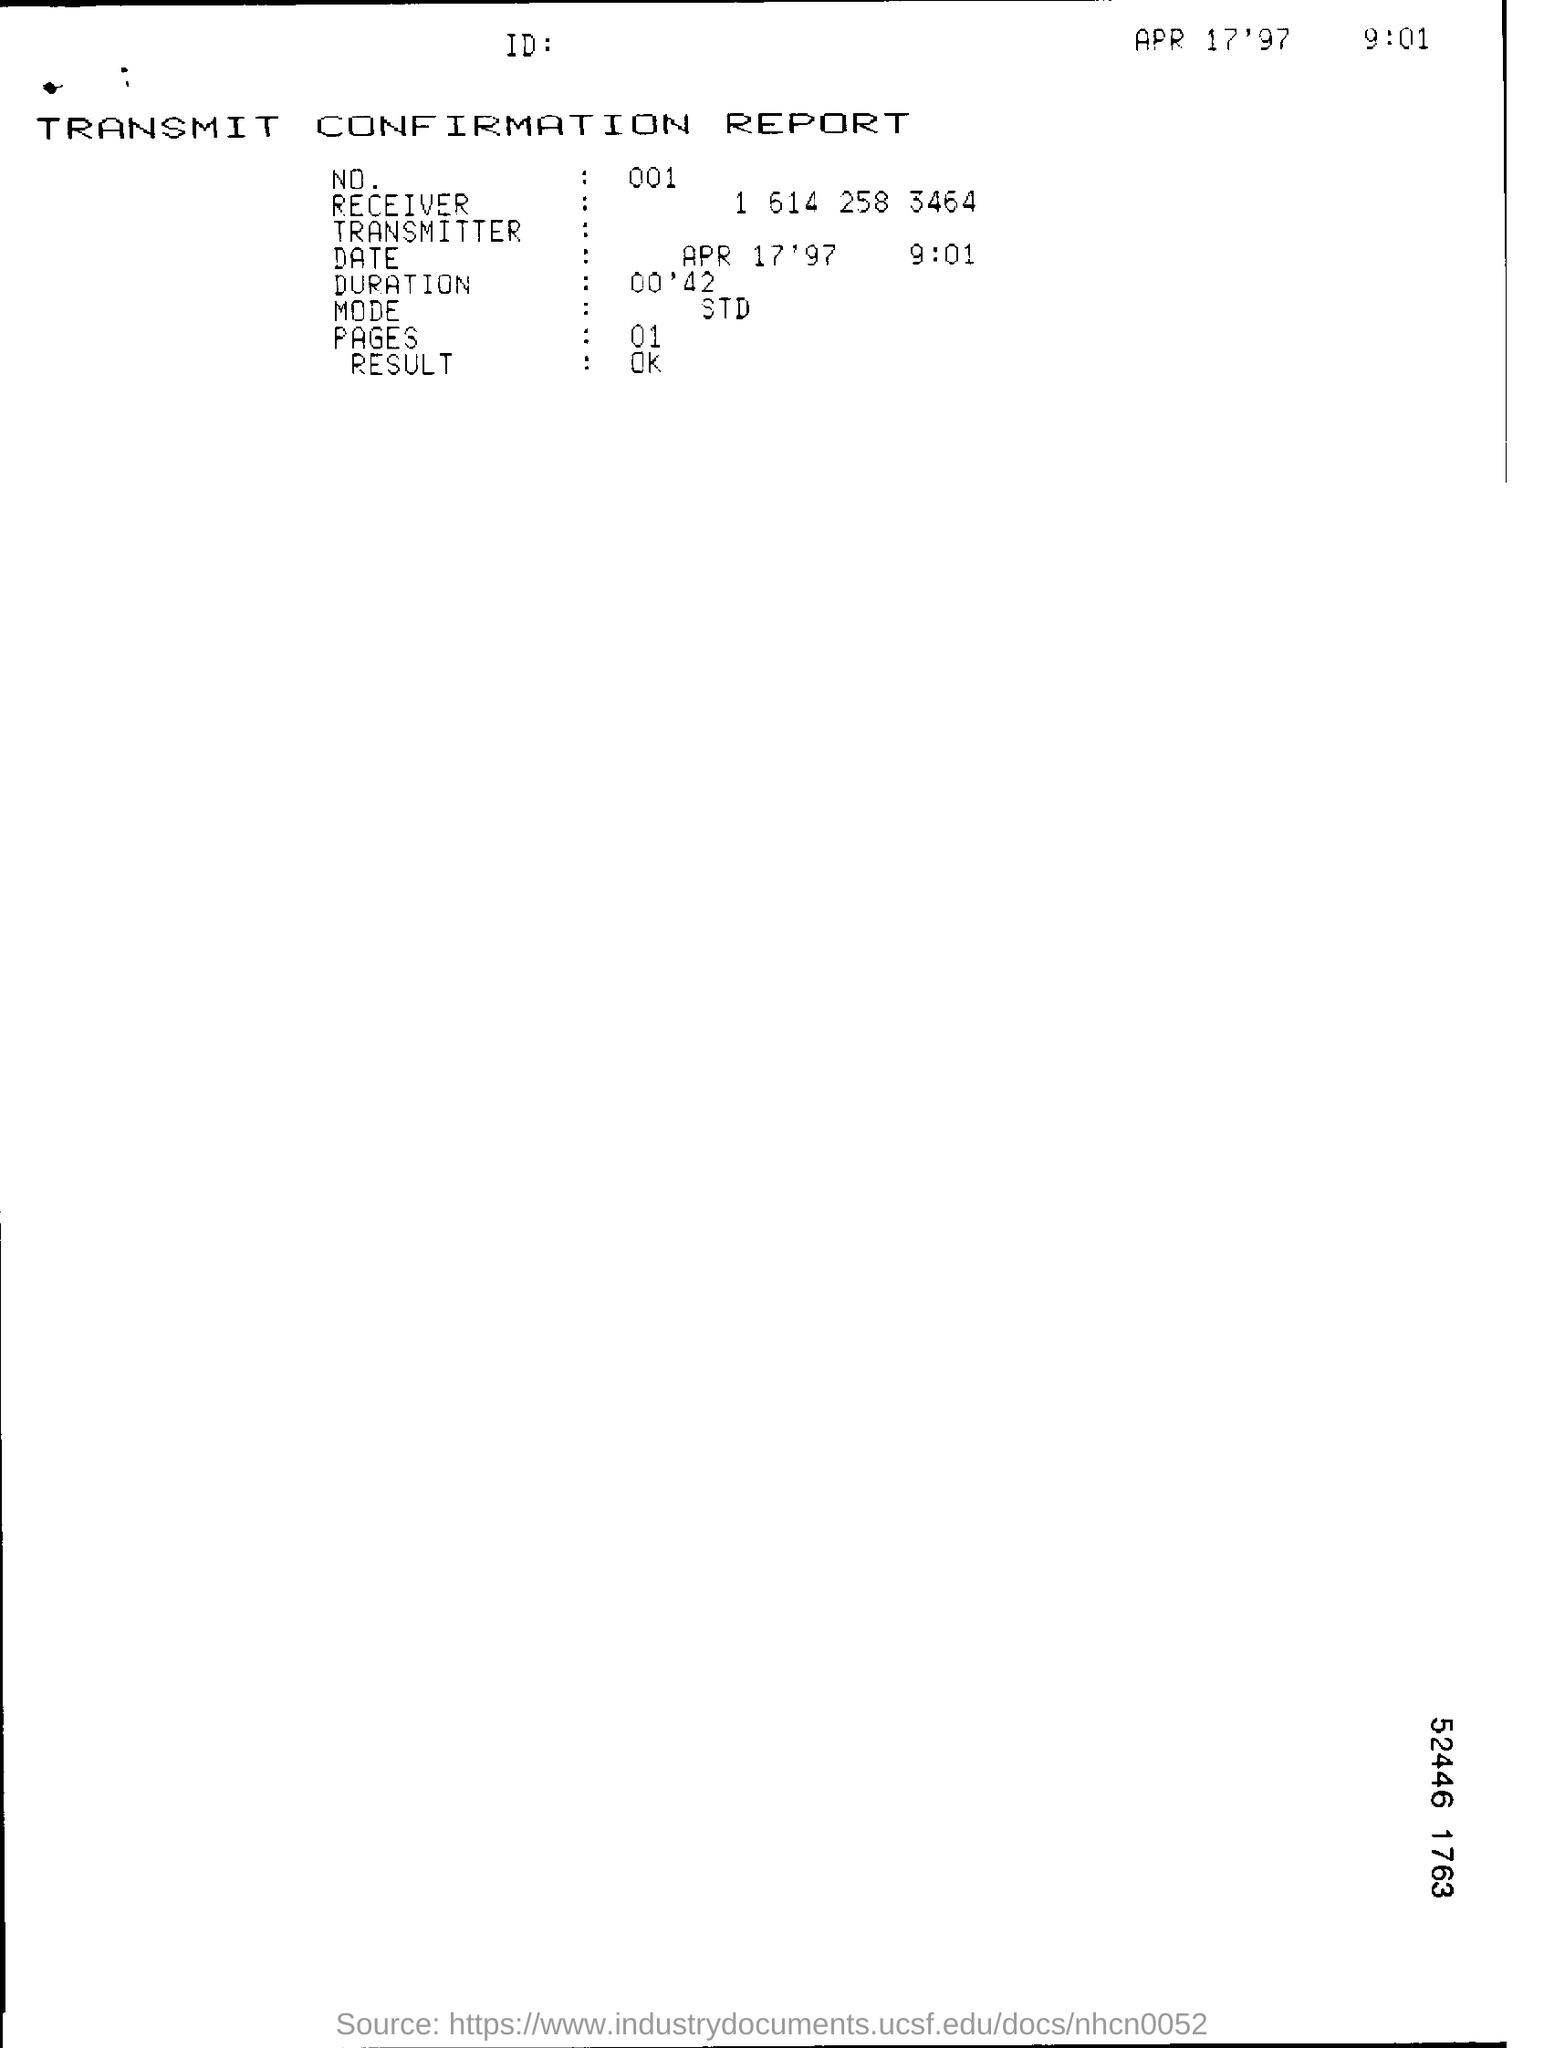Draw attention to some important aspects in this diagram. The number is 001... 